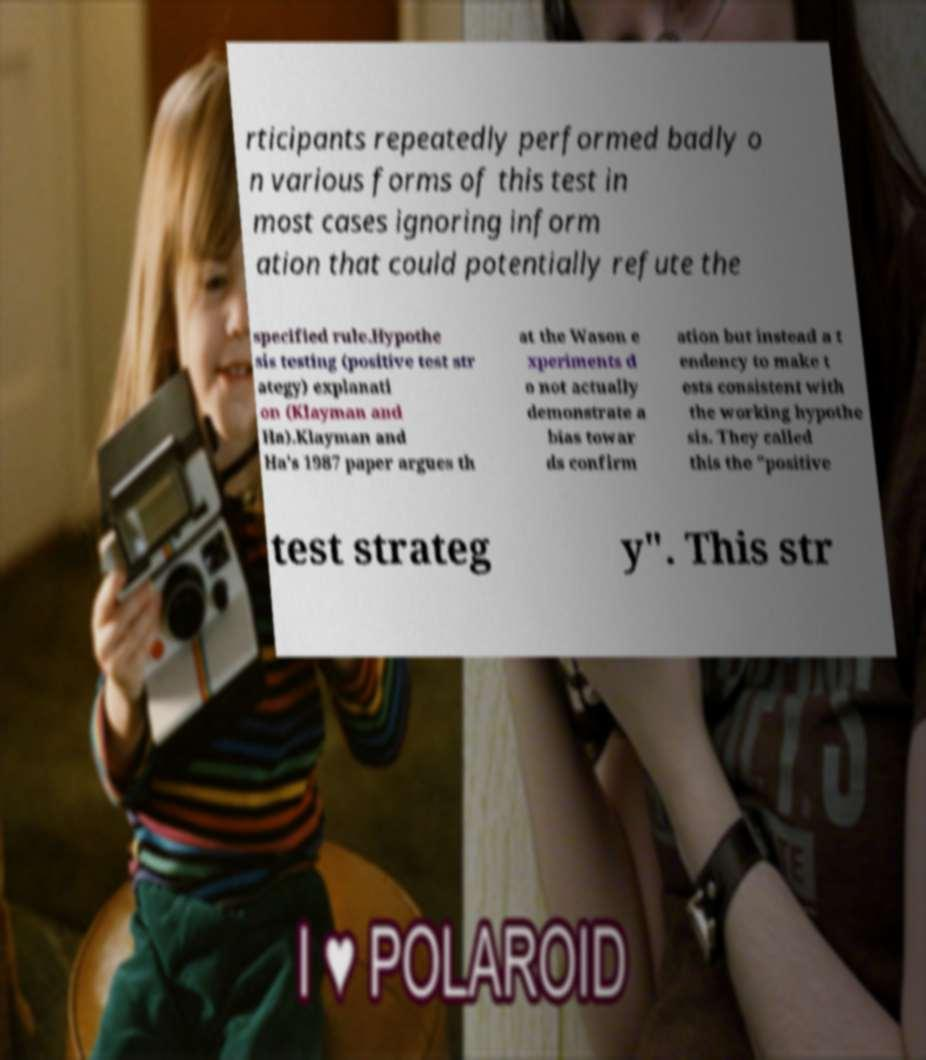Please read and relay the text visible in this image. What does it say? rticipants repeatedly performed badly o n various forms of this test in most cases ignoring inform ation that could potentially refute the specified rule.Hypothe sis testing (positive test str ategy) explanati on (Klayman and Ha).Klayman and Ha's 1987 paper argues th at the Wason e xperiments d o not actually demonstrate a bias towar ds confirm ation but instead a t endency to make t ests consistent with the working hypothe sis. They called this the "positive test strateg y". This str 